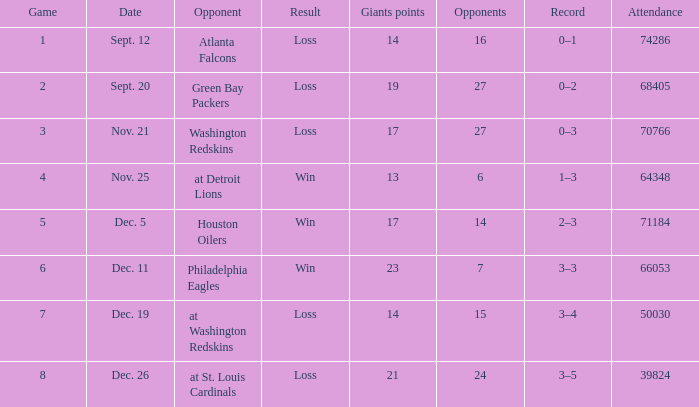What is the lowest quantity of adversaries? 6.0. 